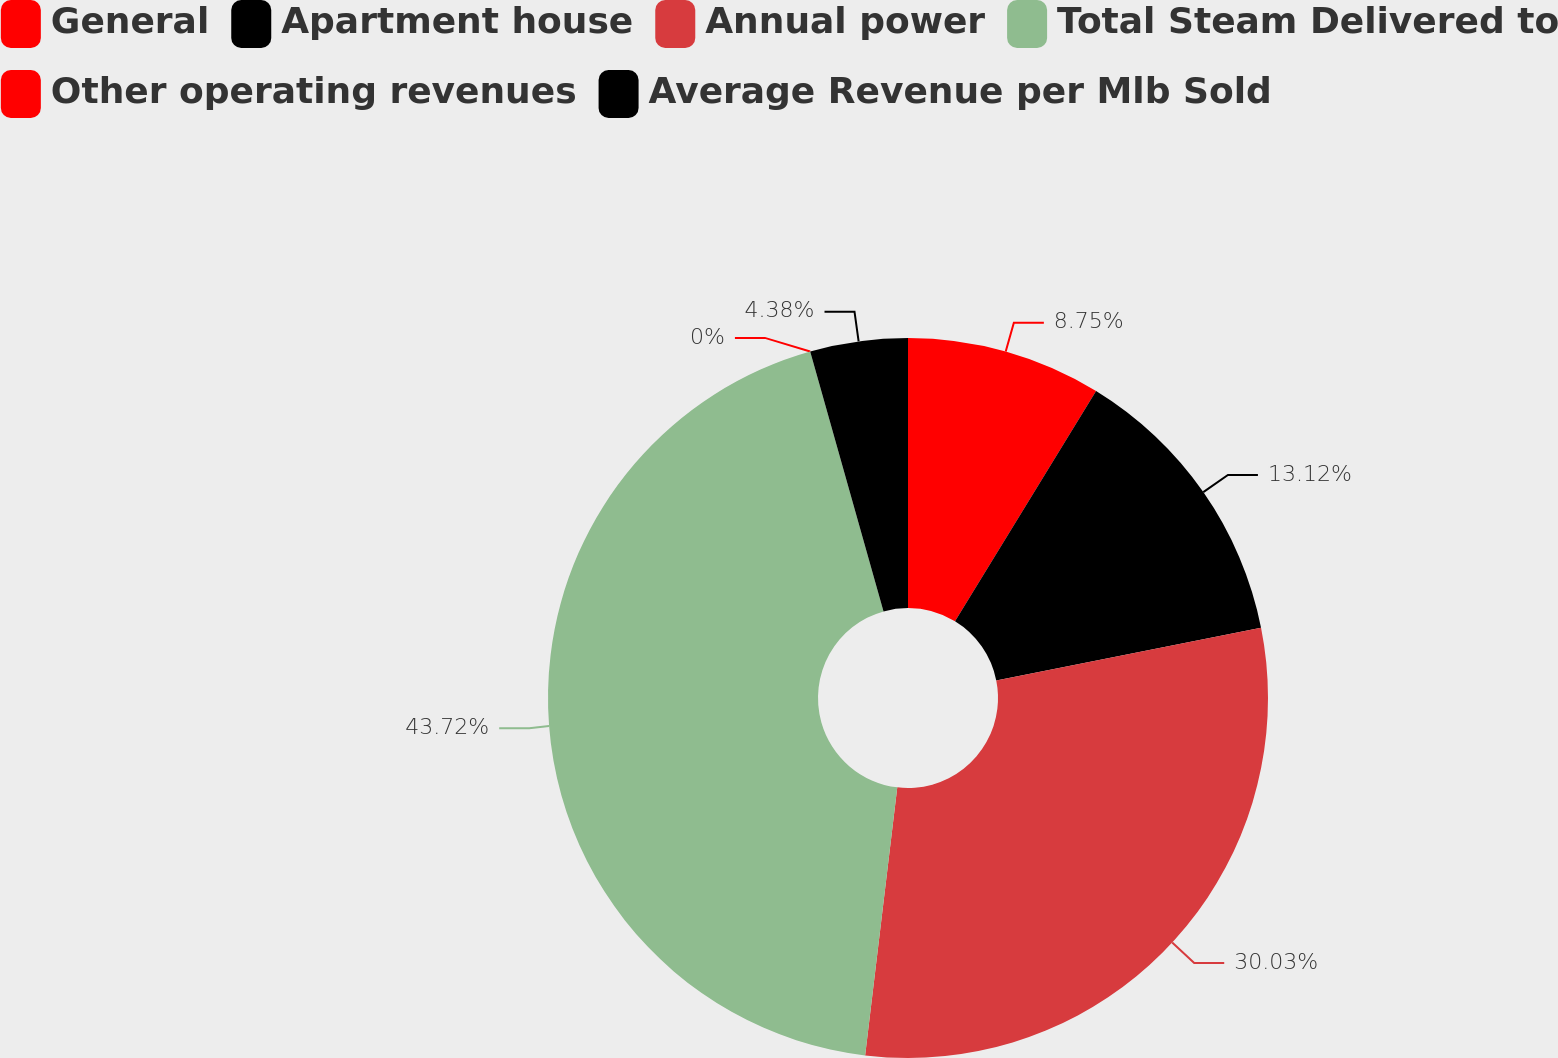Convert chart to OTSL. <chart><loc_0><loc_0><loc_500><loc_500><pie_chart><fcel>General<fcel>Apartment house<fcel>Annual power<fcel>Total Steam Delivered to<fcel>Other operating revenues<fcel>Average Revenue per Mlb Sold<nl><fcel>8.75%<fcel>13.12%<fcel>30.03%<fcel>43.72%<fcel>0.0%<fcel>4.38%<nl></chart> 